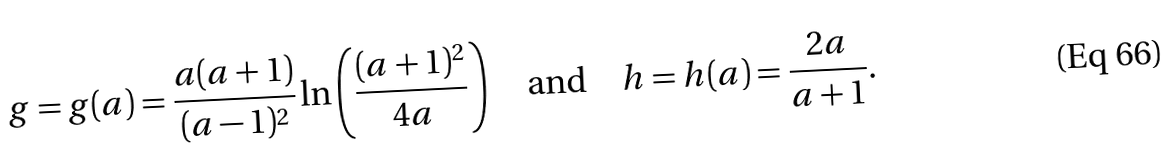Convert formula to latex. <formula><loc_0><loc_0><loc_500><loc_500>g = g ( a ) = \frac { a ( a + 1 ) } { ( a - 1 ) ^ { 2 } } \ln \left ( \frac { ( a + 1 ) ^ { 2 } } { 4 a } \right ) \quad \text {and} \quad h = h ( a ) = \frac { 2 a } { a + 1 } .</formula> 